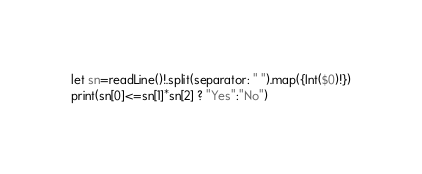Convert code to text. <code><loc_0><loc_0><loc_500><loc_500><_Swift_>let sn=readLine()!.split(separator: " ").map({Int($0)!})
print(sn[0]<=sn[1]*sn[2] ? "Yes":"No")</code> 